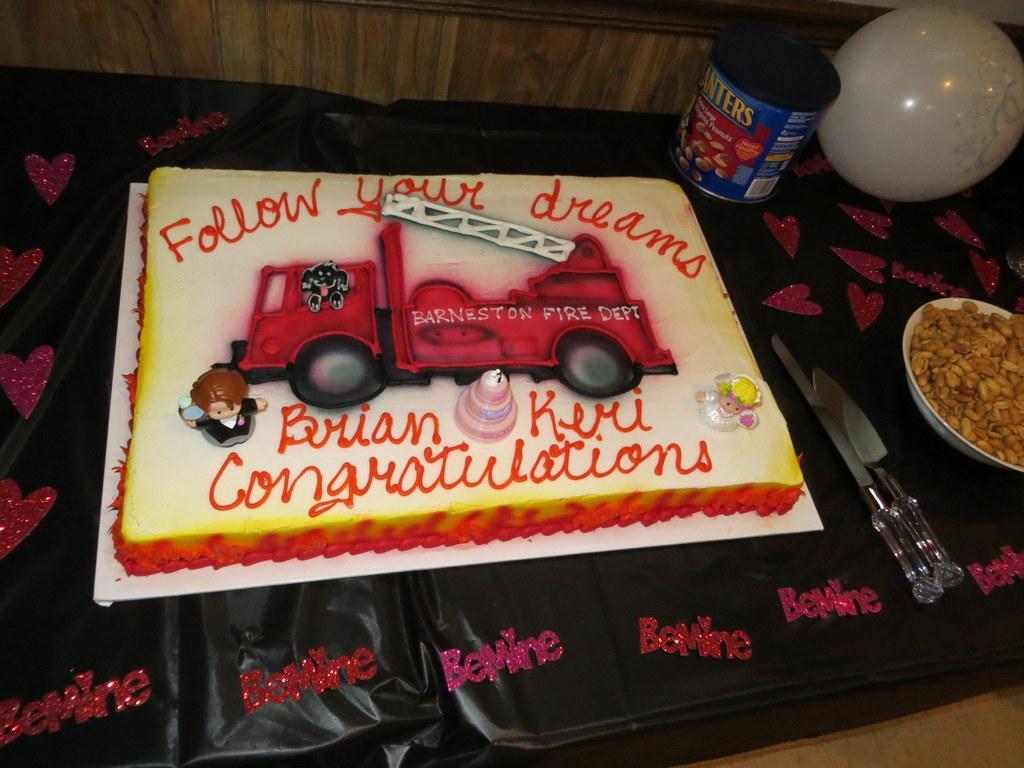In one or two sentences, can you explain what this image depicts? In this image in front there is a cake, there are nuts in a bowl, there is a box and a balloon on a black color surface. At the bottom of the image there is a floor. 